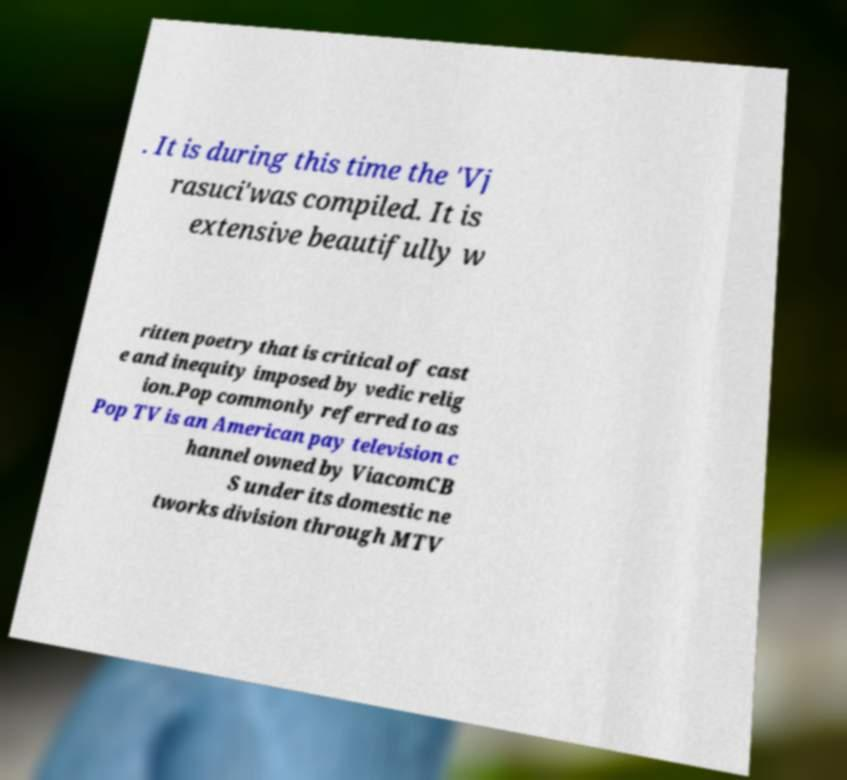What messages or text are displayed in this image? I need them in a readable, typed format. . It is during this time the 'Vj rasuci'was compiled. It is extensive beautifully w ritten poetry that is critical of cast e and inequity imposed by vedic relig ion.Pop commonly referred to as Pop TV is an American pay television c hannel owned by ViacomCB S under its domestic ne tworks division through MTV 